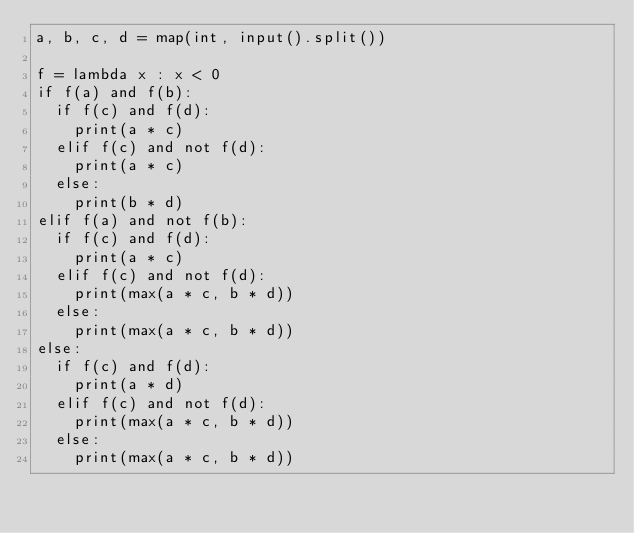Convert code to text. <code><loc_0><loc_0><loc_500><loc_500><_Python_>a, b, c, d = map(int, input().split())

f = lambda x : x < 0
if f(a) and f(b):
  if f(c) and f(d):
    print(a * c)
  elif f(c) and not f(d):
    print(a * c)
  else:
    print(b * d)
elif f(a) and not f(b):
  if f(c) and f(d):
    print(a * c)
  elif f(c) and not f(d):
    print(max(a * c, b * d))
  else:
    print(max(a * c, b * d))
else:
  if f(c) and f(d):
    print(a * d)
  elif f(c) and not f(d):
    print(max(a * c, b * d))
  else:
    print(max(a * c, b * d))</code> 